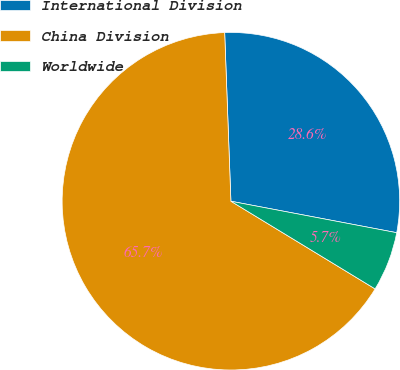Convert chart to OTSL. <chart><loc_0><loc_0><loc_500><loc_500><pie_chart><fcel>International Division<fcel>China Division<fcel>Worldwide<nl><fcel>28.57%<fcel>65.71%<fcel>5.71%<nl></chart> 